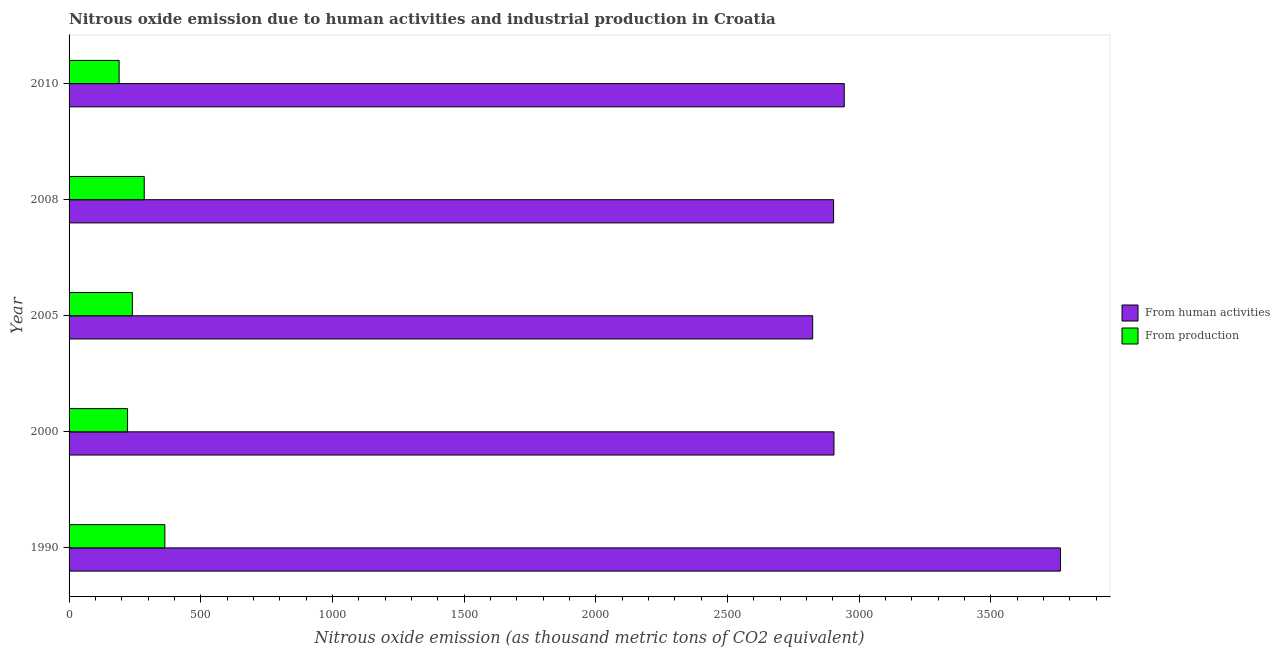How many different coloured bars are there?
Keep it short and to the point. 2. Are the number of bars per tick equal to the number of legend labels?
Keep it short and to the point. Yes. Are the number of bars on each tick of the Y-axis equal?
Your response must be concise. Yes. How many bars are there on the 3rd tick from the bottom?
Provide a short and direct response. 2. What is the label of the 1st group of bars from the top?
Make the answer very short. 2010. In how many cases, is the number of bars for a given year not equal to the number of legend labels?
Provide a succinct answer. 0. What is the amount of emissions generated from industries in 2000?
Provide a succinct answer. 222. Across all years, what is the maximum amount of emissions generated from industries?
Offer a very short reply. 363.7. Across all years, what is the minimum amount of emissions from human activities?
Provide a succinct answer. 2823.4. In which year was the amount of emissions generated from industries maximum?
Offer a very short reply. 1990. What is the total amount of emissions generated from industries in the graph?
Keep it short and to the point. 1301.5. What is the difference between the amount of emissions from human activities in 2000 and that in 2008?
Keep it short and to the point. 1.5. What is the difference between the amount of emissions generated from industries in 2005 and the amount of emissions from human activities in 1990?
Keep it short and to the point. -3523.8. What is the average amount of emissions generated from industries per year?
Offer a very short reply. 260.3. In the year 2000, what is the difference between the amount of emissions from human activities and amount of emissions generated from industries?
Keep it short and to the point. 2682.3. What is the ratio of the amount of emissions generated from industries in 2000 to that in 2008?
Give a very brief answer. 0.78. What is the difference between the highest and the second highest amount of emissions from human activities?
Your response must be concise. 820.8. What is the difference between the highest and the lowest amount of emissions generated from industries?
Your response must be concise. 173.6. Is the sum of the amount of emissions from human activities in 1990 and 2005 greater than the maximum amount of emissions generated from industries across all years?
Give a very brief answer. Yes. What does the 1st bar from the top in 1990 represents?
Keep it short and to the point. From production. What does the 1st bar from the bottom in 2008 represents?
Provide a short and direct response. From human activities. How many years are there in the graph?
Keep it short and to the point. 5. What is the difference between two consecutive major ticks on the X-axis?
Provide a short and direct response. 500. Does the graph contain any zero values?
Your answer should be very brief. No. How many legend labels are there?
Make the answer very short. 2. How are the legend labels stacked?
Keep it short and to the point. Vertical. What is the title of the graph?
Offer a terse response. Nitrous oxide emission due to human activities and industrial production in Croatia. What is the label or title of the X-axis?
Your answer should be compact. Nitrous oxide emission (as thousand metric tons of CO2 equivalent). What is the label or title of the Y-axis?
Your answer should be compact. Year. What is the Nitrous oxide emission (as thousand metric tons of CO2 equivalent) in From human activities in 1990?
Your response must be concise. 3764.1. What is the Nitrous oxide emission (as thousand metric tons of CO2 equivalent) in From production in 1990?
Your response must be concise. 363.7. What is the Nitrous oxide emission (as thousand metric tons of CO2 equivalent) in From human activities in 2000?
Ensure brevity in your answer.  2904.3. What is the Nitrous oxide emission (as thousand metric tons of CO2 equivalent) of From production in 2000?
Offer a very short reply. 222. What is the Nitrous oxide emission (as thousand metric tons of CO2 equivalent) of From human activities in 2005?
Ensure brevity in your answer.  2823.4. What is the Nitrous oxide emission (as thousand metric tons of CO2 equivalent) in From production in 2005?
Provide a short and direct response. 240.3. What is the Nitrous oxide emission (as thousand metric tons of CO2 equivalent) in From human activities in 2008?
Offer a very short reply. 2902.8. What is the Nitrous oxide emission (as thousand metric tons of CO2 equivalent) in From production in 2008?
Offer a very short reply. 285.4. What is the Nitrous oxide emission (as thousand metric tons of CO2 equivalent) of From human activities in 2010?
Offer a very short reply. 2943.3. What is the Nitrous oxide emission (as thousand metric tons of CO2 equivalent) in From production in 2010?
Provide a short and direct response. 190.1. Across all years, what is the maximum Nitrous oxide emission (as thousand metric tons of CO2 equivalent) in From human activities?
Your response must be concise. 3764.1. Across all years, what is the maximum Nitrous oxide emission (as thousand metric tons of CO2 equivalent) of From production?
Your answer should be compact. 363.7. Across all years, what is the minimum Nitrous oxide emission (as thousand metric tons of CO2 equivalent) of From human activities?
Give a very brief answer. 2823.4. Across all years, what is the minimum Nitrous oxide emission (as thousand metric tons of CO2 equivalent) of From production?
Offer a terse response. 190.1. What is the total Nitrous oxide emission (as thousand metric tons of CO2 equivalent) in From human activities in the graph?
Offer a very short reply. 1.53e+04. What is the total Nitrous oxide emission (as thousand metric tons of CO2 equivalent) in From production in the graph?
Provide a succinct answer. 1301.5. What is the difference between the Nitrous oxide emission (as thousand metric tons of CO2 equivalent) in From human activities in 1990 and that in 2000?
Offer a terse response. 859.8. What is the difference between the Nitrous oxide emission (as thousand metric tons of CO2 equivalent) of From production in 1990 and that in 2000?
Ensure brevity in your answer.  141.7. What is the difference between the Nitrous oxide emission (as thousand metric tons of CO2 equivalent) of From human activities in 1990 and that in 2005?
Your answer should be very brief. 940.7. What is the difference between the Nitrous oxide emission (as thousand metric tons of CO2 equivalent) in From production in 1990 and that in 2005?
Offer a very short reply. 123.4. What is the difference between the Nitrous oxide emission (as thousand metric tons of CO2 equivalent) in From human activities in 1990 and that in 2008?
Provide a short and direct response. 861.3. What is the difference between the Nitrous oxide emission (as thousand metric tons of CO2 equivalent) in From production in 1990 and that in 2008?
Provide a short and direct response. 78.3. What is the difference between the Nitrous oxide emission (as thousand metric tons of CO2 equivalent) of From human activities in 1990 and that in 2010?
Provide a succinct answer. 820.8. What is the difference between the Nitrous oxide emission (as thousand metric tons of CO2 equivalent) in From production in 1990 and that in 2010?
Provide a succinct answer. 173.6. What is the difference between the Nitrous oxide emission (as thousand metric tons of CO2 equivalent) in From human activities in 2000 and that in 2005?
Provide a succinct answer. 80.9. What is the difference between the Nitrous oxide emission (as thousand metric tons of CO2 equivalent) of From production in 2000 and that in 2005?
Offer a terse response. -18.3. What is the difference between the Nitrous oxide emission (as thousand metric tons of CO2 equivalent) in From human activities in 2000 and that in 2008?
Give a very brief answer. 1.5. What is the difference between the Nitrous oxide emission (as thousand metric tons of CO2 equivalent) in From production in 2000 and that in 2008?
Your answer should be very brief. -63.4. What is the difference between the Nitrous oxide emission (as thousand metric tons of CO2 equivalent) in From human activities in 2000 and that in 2010?
Give a very brief answer. -39. What is the difference between the Nitrous oxide emission (as thousand metric tons of CO2 equivalent) of From production in 2000 and that in 2010?
Keep it short and to the point. 31.9. What is the difference between the Nitrous oxide emission (as thousand metric tons of CO2 equivalent) in From human activities in 2005 and that in 2008?
Ensure brevity in your answer.  -79.4. What is the difference between the Nitrous oxide emission (as thousand metric tons of CO2 equivalent) in From production in 2005 and that in 2008?
Keep it short and to the point. -45.1. What is the difference between the Nitrous oxide emission (as thousand metric tons of CO2 equivalent) of From human activities in 2005 and that in 2010?
Make the answer very short. -119.9. What is the difference between the Nitrous oxide emission (as thousand metric tons of CO2 equivalent) in From production in 2005 and that in 2010?
Your answer should be very brief. 50.2. What is the difference between the Nitrous oxide emission (as thousand metric tons of CO2 equivalent) in From human activities in 2008 and that in 2010?
Make the answer very short. -40.5. What is the difference between the Nitrous oxide emission (as thousand metric tons of CO2 equivalent) of From production in 2008 and that in 2010?
Offer a very short reply. 95.3. What is the difference between the Nitrous oxide emission (as thousand metric tons of CO2 equivalent) of From human activities in 1990 and the Nitrous oxide emission (as thousand metric tons of CO2 equivalent) of From production in 2000?
Your response must be concise. 3542.1. What is the difference between the Nitrous oxide emission (as thousand metric tons of CO2 equivalent) in From human activities in 1990 and the Nitrous oxide emission (as thousand metric tons of CO2 equivalent) in From production in 2005?
Your answer should be very brief. 3523.8. What is the difference between the Nitrous oxide emission (as thousand metric tons of CO2 equivalent) in From human activities in 1990 and the Nitrous oxide emission (as thousand metric tons of CO2 equivalent) in From production in 2008?
Your answer should be compact. 3478.7. What is the difference between the Nitrous oxide emission (as thousand metric tons of CO2 equivalent) in From human activities in 1990 and the Nitrous oxide emission (as thousand metric tons of CO2 equivalent) in From production in 2010?
Your answer should be compact. 3574. What is the difference between the Nitrous oxide emission (as thousand metric tons of CO2 equivalent) of From human activities in 2000 and the Nitrous oxide emission (as thousand metric tons of CO2 equivalent) of From production in 2005?
Make the answer very short. 2664. What is the difference between the Nitrous oxide emission (as thousand metric tons of CO2 equivalent) of From human activities in 2000 and the Nitrous oxide emission (as thousand metric tons of CO2 equivalent) of From production in 2008?
Your answer should be very brief. 2618.9. What is the difference between the Nitrous oxide emission (as thousand metric tons of CO2 equivalent) in From human activities in 2000 and the Nitrous oxide emission (as thousand metric tons of CO2 equivalent) in From production in 2010?
Provide a short and direct response. 2714.2. What is the difference between the Nitrous oxide emission (as thousand metric tons of CO2 equivalent) in From human activities in 2005 and the Nitrous oxide emission (as thousand metric tons of CO2 equivalent) in From production in 2008?
Provide a short and direct response. 2538. What is the difference between the Nitrous oxide emission (as thousand metric tons of CO2 equivalent) in From human activities in 2005 and the Nitrous oxide emission (as thousand metric tons of CO2 equivalent) in From production in 2010?
Your answer should be very brief. 2633.3. What is the difference between the Nitrous oxide emission (as thousand metric tons of CO2 equivalent) of From human activities in 2008 and the Nitrous oxide emission (as thousand metric tons of CO2 equivalent) of From production in 2010?
Offer a very short reply. 2712.7. What is the average Nitrous oxide emission (as thousand metric tons of CO2 equivalent) of From human activities per year?
Your response must be concise. 3067.58. What is the average Nitrous oxide emission (as thousand metric tons of CO2 equivalent) in From production per year?
Give a very brief answer. 260.3. In the year 1990, what is the difference between the Nitrous oxide emission (as thousand metric tons of CO2 equivalent) of From human activities and Nitrous oxide emission (as thousand metric tons of CO2 equivalent) of From production?
Make the answer very short. 3400.4. In the year 2000, what is the difference between the Nitrous oxide emission (as thousand metric tons of CO2 equivalent) in From human activities and Nitrous oxide emission (as thousand metric tons of CO2 equivalent) in From production?
Make the answer very short. 2682.3. In the year 2005, what is the difference between the Nitrous oxide emission (as thousand metric tons of CO2 equivalent) of From human activities and Nitrous oxide emission (as thousand metric tons of CO2 equivalent) of From production?
Your answer should be very brief. 2583.1. In the year 2008, what is the difference between the Nitrous oxide emission (as thousand metric tons of CO2 equivalent) in From human activities and Nitrous oxide emission (as thousand metric tons of CO2 equivalent) in From production?
Provide a succinct answer. 2617.4. In the year 2010, what is the difference between the Nitrous oxide emission (as thousand metric tons of CO2 equivalent) of From human activities and Nitrous oxide emission (as thousand metric tons of CO2 equivalent) of From production?
Your response must be concise. 2753.2. What is the ratio of the Nitrous oxide emission (as thousand metric tons of CO2 equivalent) of From human activities in 1990 to that in 2000?
Ensure brevity in your answer.  1.3. What is the ratio of the Nitrous oxide emission (as thousand metric tons of CO2 equivalent) in From production in 1990 to that in 2000?
Offer a very short reply. 1.64. What is the ratio of the Nitrous oxide emission (as thousand metric tons of CO2 equivalent) in From human activities in 1990 to that in 2005?
Give a very brief answer. 1.33. What is the ratio of the Nitrous oxide emission (as thousand metric tons of CO2 equivalent) of From production in 1990 to that in 2005?
Your response must be concise. 1.51. What is the ratio of the Nitrous oxide emission (as thousand metric tons of CO2 equivalent) of From human activities in 1990 to that in 2008?
Ensure brevity in your answer.  1.3. What is the ratio of the Nitrous oxide emission (as thousand metric tons of CO2 equivalent) in From production in 1990 to that in 2008?
Your answer should be very brief. 1.27. What is the ratio of the Nitrous oxide emission (as thousand metric tons of CO2 equivalent) of From human activities in 1990 to that in 2010?
Your answer should be compact. 1.28. What is the ratio of the Nitrous oxide emission (as thousand metric tons of CO2 equivalent) of From production in 1990 to that in 2010?
Provide a short and direct response. 1.91. What is the ratio of the Nitrous oxide emission (as thousand metric tons of CO2 equivalent) in From human activities in 2000 to that in 2005?
Provide a short and direct response. 1.03. What is the ratio of the Nitrous oxide emission (as thousand metric tons of CO2 equivalent) in From production in 2000 to that in 2005?
Your answer should be very brief. 0.92. What is the ratio of the Nitrous oxide emission (as thousand metric tons of CO2 equivalent) in From production in 2000 to that in 2008?
Offer a very short reply. 0.78. What is the ratio of the Nitrous oxide emission (as thousand metric tons of CO2 equivalent) in From human activities in 2000 to that in 2010?
Your response must be concise. 0.99. What is the ratio of the Nitrous oxide emission (as thousand metric tons of CO2 equivalent) in From production in 2000 to that in 2010?
Your response must be concise. 1.17. What is the ratio of the Nitrous oxide emission (as thousand metric tons of CO2 equivalent) in From human activities in 2005 to that in 2008?
Your answer should be compact. 0.97. What is the ratio of the Nitrous oxide emission (as thousand metric tons of CO2 equivalent) in From production in 2005 to that in 2008?
Your response must be concise. 0.84. What is the ratio of the Nitrous oxide emission (as thousand metric tons of CO2 equivalent) in From human activities in 2005 to that in 2010?
Your response must be concise. 0.96. What is the ratio of the Nitrous oxide emission (as thousand metric tons of CO2 equivalent) of From production in 2005 to that in 2010?
Ensure brevity in your answer.  1.26. What is the ratio of the Nitrous oxide emission (as thousand metric tons of CO2 equivalent) in From human activities in 2008 to that in 2010?
Provide a succinct answer. 0.99. What is the ratio of the Nitrous oxide emission (as thousand metric tons of CO2 equivalent) in From production in 2008 to that in 2010?
Ensure brevity in your answer.  1.5. What is the difference between the highest and the second highest Nitrous oxide emission (as thousand metric tons of CO2 equivalent) in From human activities?
Keep it short and to the point. 820.8. What is the difference between the highest and the second highest Nitrous oxide emission (as thousand metric tons of CO2 equivalent) in From production?
Your answer should be compact. 78.3. What is the difference between the highest and the lowest Nitrous oxide emission (as thousand metric tons of CO2 equivalent) of From human activities?
Provide a short and direct response. 940.7. What is the difference between the highest and the lowest Nitrous oxide emission (as thousand metric tons of CO2 equivalent) of From production?
Give a very brief answer. 173.6. 